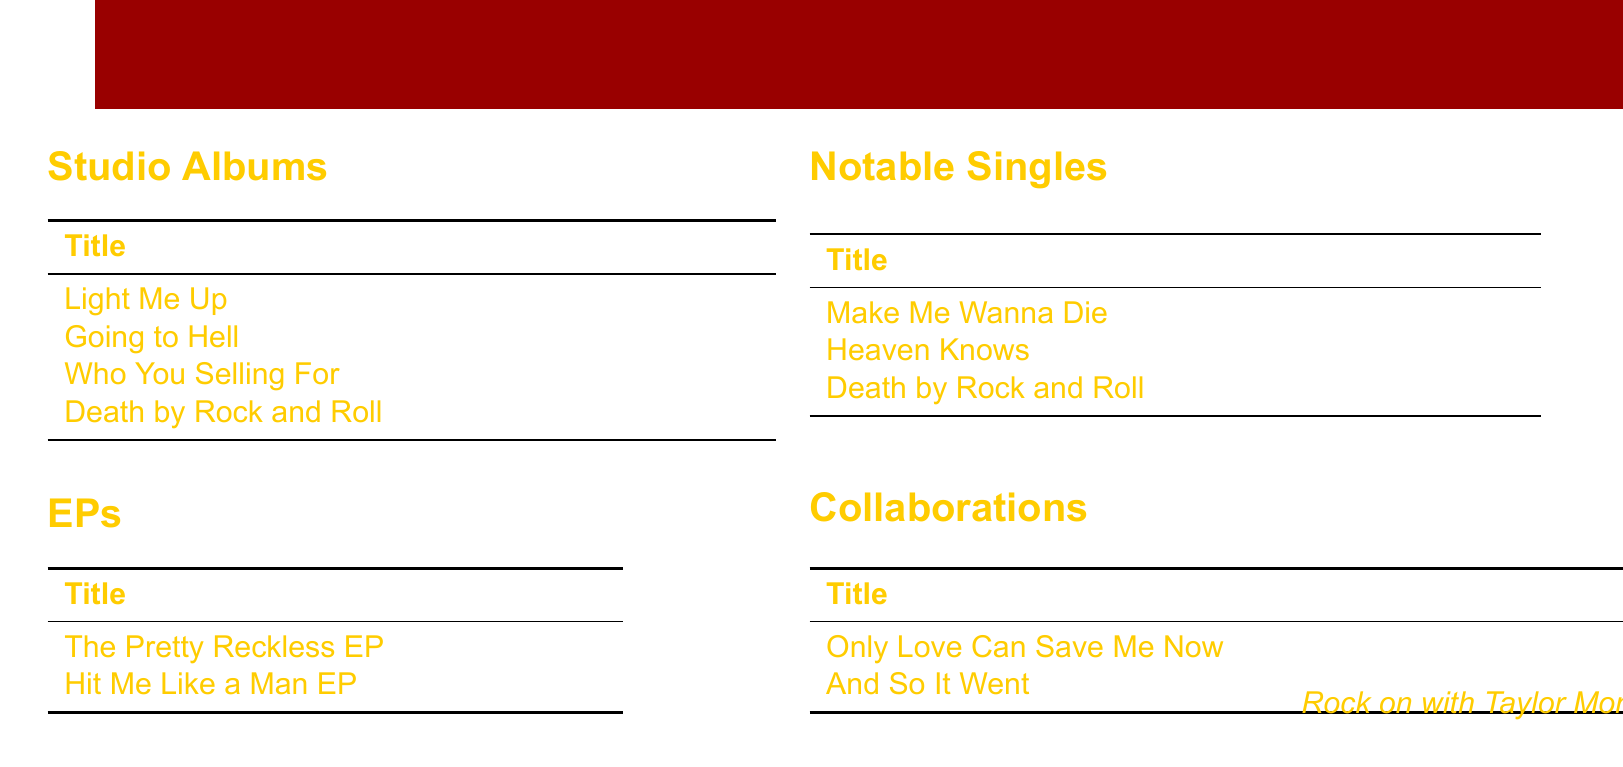What is the title of The Pretty Reckless' debut album? The title of their debut album can be found in the studio albums section, where it lists "Light Me Up" as the first entry.
Answer: Light Me Up When was the album "Going to Hell" released? The release date for "Going to Hell" is specified in the studio albums section next to its title.
Answer: Mar 18, 2014 What is the US peak position of the album "Who You Selling For"? The US peak position can be found in the studio albums section next to the album title "Who You Selling For".
Answer: 13 Which single by The Pretty Reckless reached number 1 on the US Rock chart first? The singles section lists "Make Me Wanna Die" as the first single that achieved the number 1 position on the US Rock chart.
Answer: Make Me Wanna Die Name a featured artist in the collaboration titled "Only Love Can Save Me Now". The featured artists for "Only Love Can Save Me Now" are listed next to the title in the collaborations section.
Answer: Matt Cameron & Kim Thayil What is the total number of studio albums listed in the document? The number of studio albums is indicated by counting the entries in the studio albums section.
Answer: 4 Which EP was released on June 22, 2010? The release date for the EP can be found in the EPs section next to its title.
Answer: The Pretty Reckless EP What is the title of the last studio album mentioned in the document? The last studio album is the final entry in the studio albums section.
Answer: Death by Rock and Roll How many notable singles are listed in the document? The total number of notable singles can be found by counting the entries in the singles section.
Answer: 3 